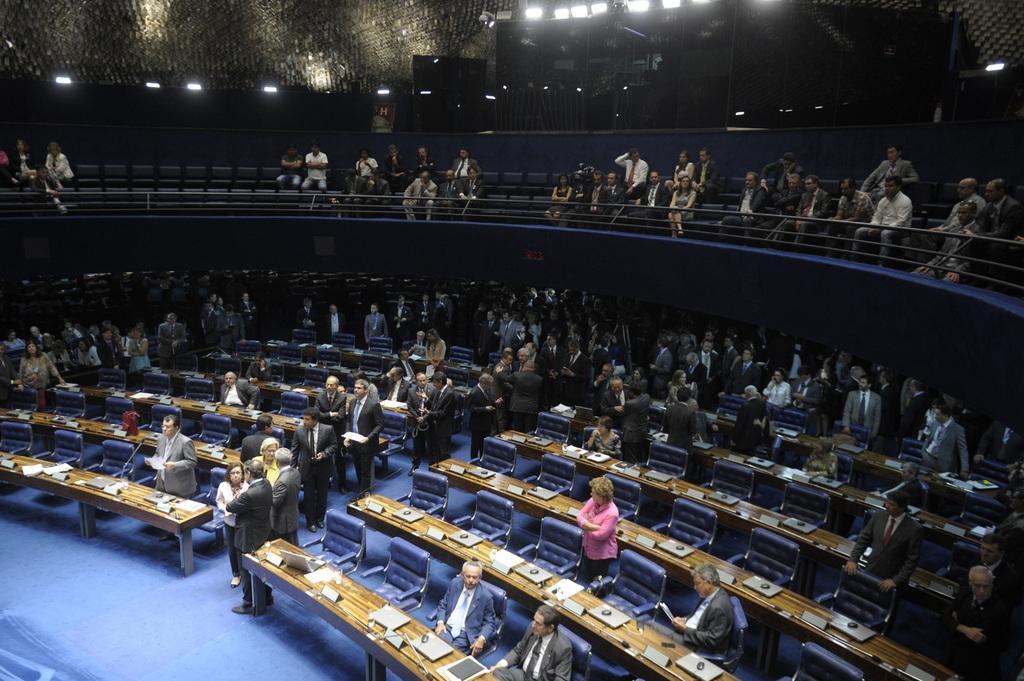How would you summarize this image in a sentence or two? In this image I can see a conference hall in the hall I can see benches , chairs and persons, systems and mouse kept on table , there is a fence , in front of fence there are few persons standing and few persons sitting on chair ,at the there few lights visible. 